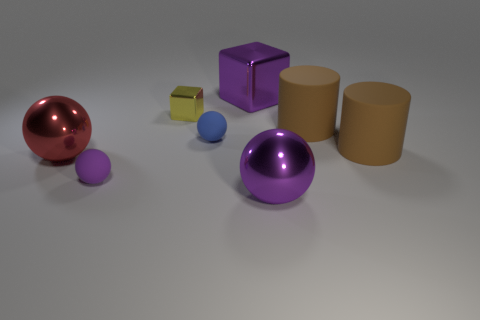There is a big ball on the right side of the small matte sphere that is in front of the red metal ball; what number of big purple metallic things are behind it?
Your response must be concise. 1. Do the large rubber object behind the blue object and the rubber cylinder that is in front of the tiny blue thing have the same color?
Offer a terse response. Yes. Is there anything else that is the same color as the small block?
Your response must be concise. No. There is a large sphere that is on the right side of the block in front of the big purple block; what color is it?
Provide a short and direct response. Purple. Are there any yellow metallic cylinders?
Your answer should be very brief. No. There is a metallic object that is both on the right side of the blue rubber thing and in front of the small blue thing; what color is it?
Your response must be concise. Purple. Do the purple sphere on the right side of the tiny blue rubber ball and the purple object that is behind the purple rubber thing have the same size?
Make the answer very short. Yes. How many other objects are there of the same size as the red metal thing?
Provide a succinct answer. 4. There is a large sphere that is to the right of the large red metallic thing; what number of small yellow metal objects are on the right side of it?
Ensure brevity in your answer.  0. Are there fewer rubber spheres that are behind the tiny purple rubber sphere than tiny purple blocks?
Provide a short and direct response. No. 